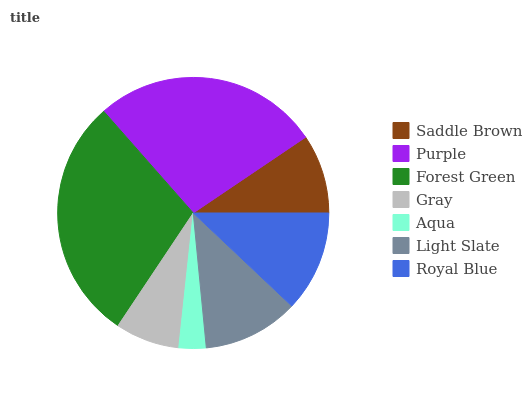Is Aqua the minimum?
Answer yes or no. Yes. Is Forest Green the maximum?
Answer yes or no. Yes. Is Purple the minimum?
Answer yes or no. No. Is Purple the maximum?
Answer yes or no. No. Is Purple greater than Saddle Brown?
Answer yes or no. Yes. Is Saddle Brown less than Purple?
Answer yes or no. Yes. Is Saddle Brown greater than Purple?
Answer yes or no. No. Is Purple less than Saddle Brown?
Answer yes or no. No. Is Light Slate the high median?
Answer yes or no. Yes. Is Light Slate the low median?
Answer yes or no. Yes. Is Saddle Brown the high median?
Answer yes or no. No. Is Saddle Brown the low median?
Answer yes or no. No. 